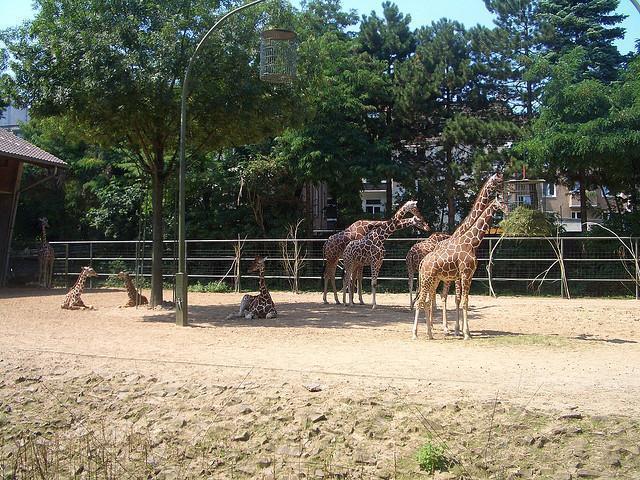What is the giraffe in the middle resting in?
Answer the question by selecting the correct answer among the 4 following choices and explain your choice with a short sentence. The answer should be formatted with the following format: `Answer: choice
Rationale: rationale.`
Options: Hay, grass, shade, bath. Answer: shade.
Rationale: That area of sand is a darker color. What animals can be seen?
From the following four choices, select the correct answer to address the question.
Options: Cows, antelopes, giraffes, horses. Giraffes. 